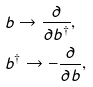Convert formula to latex. <formula><loc_0><loc_0><loc_500><loc_500>& b \to \frac { \partial } { \partial b ^ { \dagger } } , \\ & b ^ { \dagger } \to - \frac { \partial } { \partial b } ,</formula> 